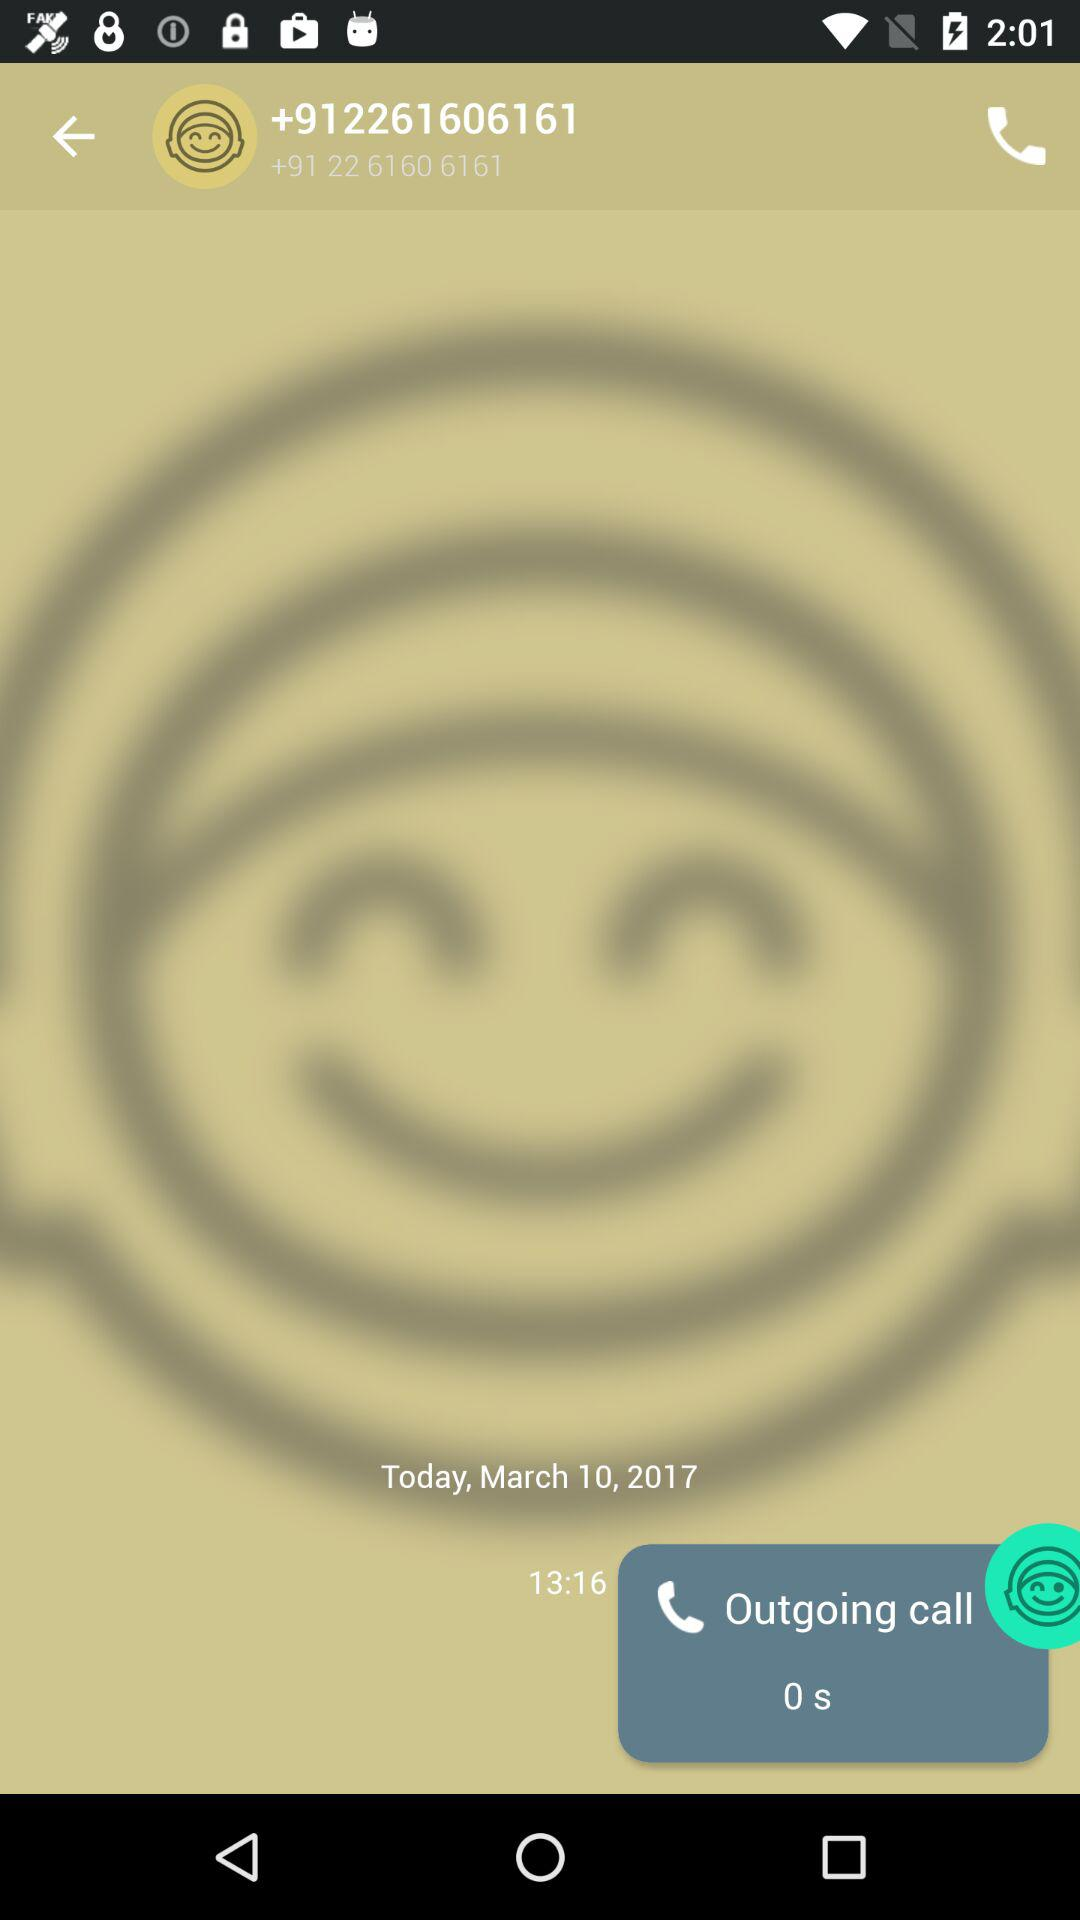What is the shown date? The shown date is March 10, 2017. 